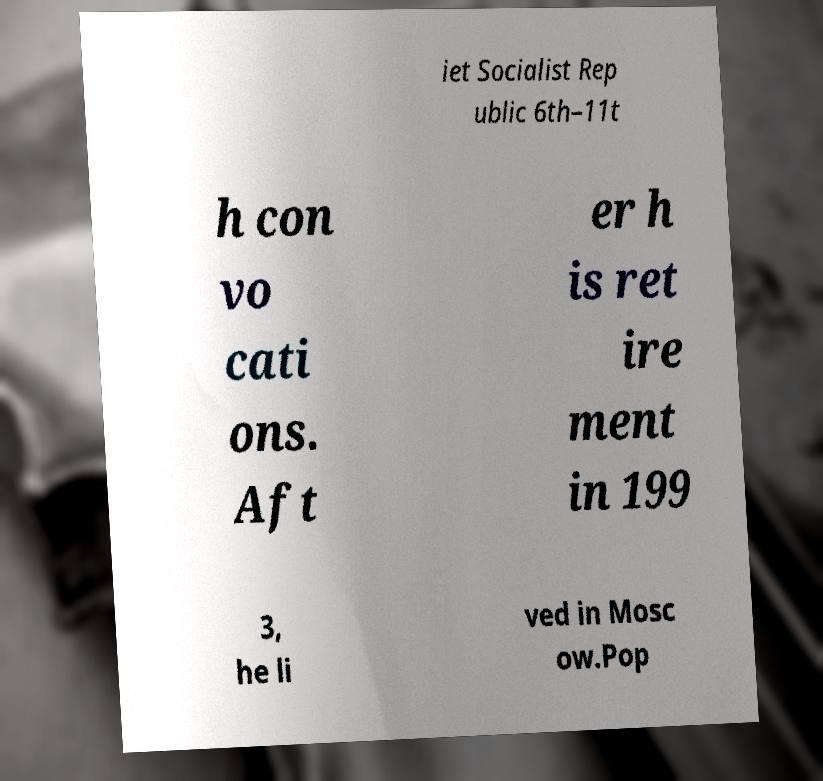Please identify and transcribe the text found in this image. iet Socialist Rep ublic 6th–11t h con vo cati ons. Aft er h is ret ire ment in 199 3, he li ved in Mosc ow.Pop 